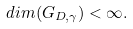Convert formula to latex. <formula><loc_0><loc_0><loc_500><loc_500>d i m ( G _ { D , \gamma } ) < \infty .</formula> 